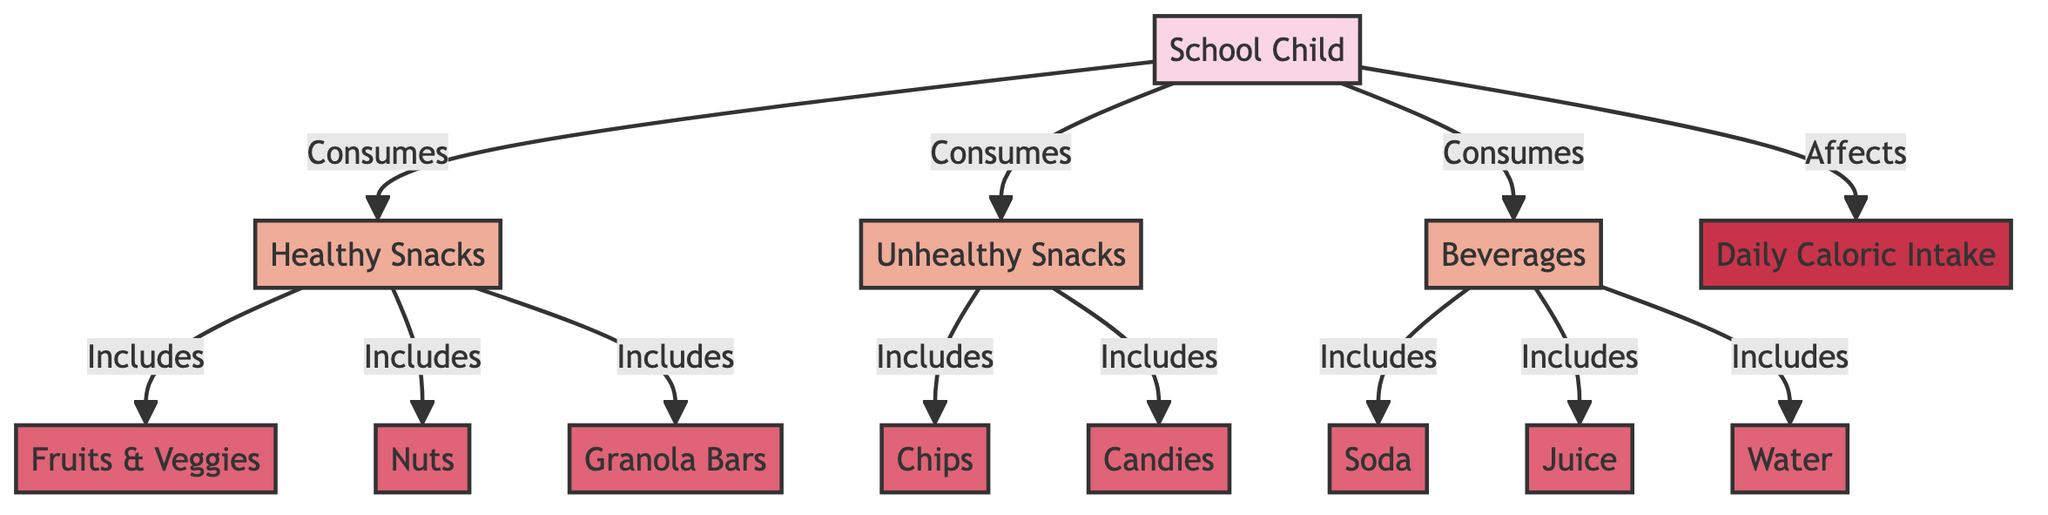What are the two categories of snacks represented in the diagram? The diagram shows two categories of snacks: healthy snacks and unhealthy snacks. These are explicitly labeled and organized within the flowchart, making it easy to identify them.
Answer: healthy snacks, unhealthy snacks Which beverages are listed in the diagram? The diagram categorizes beverages into three types: soda, juice, and water. These items are grouped under the beverages category, allowing for straightforward identification of the included items.
Answer: soda, juice, water How many types of healthy snacks are mentioned? Within the healthy snacks category, the diagram specifies three types: fruits & veggies, nuts, and granola bars. Counting these items indicates that there are three distinct types of healthy snacks presented.
Answer: 3 What does the school child consume that affects their daily caloric intake? The diagram indicates that the school child consumes healthy snacks, unhealthy snacks, and beverages, all of which are linked to affecting the daily caloric intake. Therefore, these food types are relevant to caloric intake.
Answer: healthy snacks, unhealthy snacks, beverages Which unhealthy snacks are included in the diagram? The diagram lists two types of unhealthy snacks: chips and candies. These specific items are given under the unhealthy snacks category, clearly identifying them as part of this classification.
Answer: chips, candies How do healthy snacks relate to daily caloric intake? According to the diagram, healthy snacks are consumed by the school child and are part of the flow that leads to affecting the daily caloric intake. This indicates a direct relationship in the context of consumption and caloric impact.
Answer: Affects daily caloric intake What is the relationship between beverages and daily caloric intake? The diagram shows that beverages are consumed by the school child and they also directly affect the daily caloric intake. This establishes a clear link between the beverages consumed and their impact on total caloric consumption.
Answer: Affects daily caloric intake 